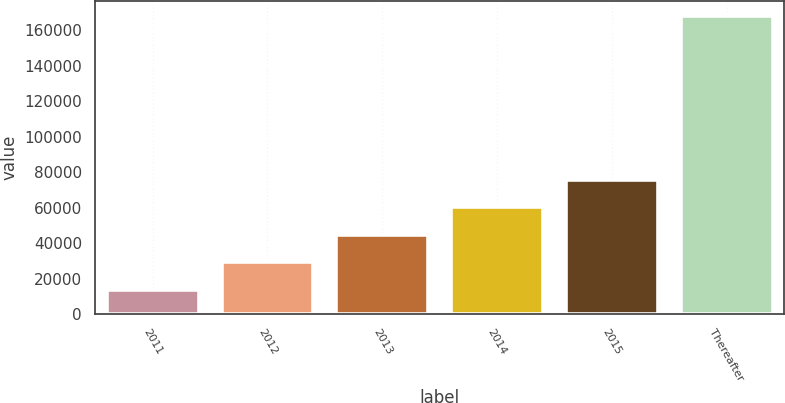Convert chart. <chart><loc_0><loc_0><loc_500><loc_500><bar_chart><fcel>2011<fcel>2012<fcel>2013<fcel>2014<fcel>2015<fcel>Thereafter<nl><fcel>13815<fcel>29263.3<fcel>44711.6<fcel>60159.9<fcel>75608.2<fcel>168298<nl></chart> 